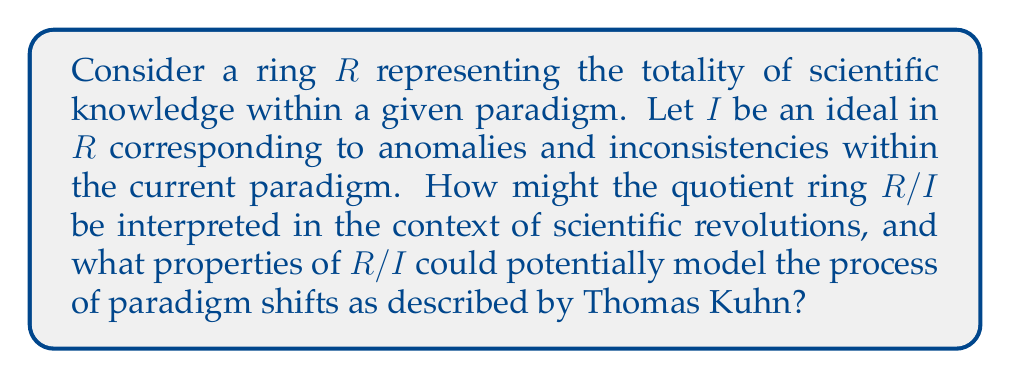Provide a solution to this math problem. To approach this question, we need to consider the properties of quotient rings and how they might relate to scientific revolutions and paradigm shifts:

1. Formation of $R/I$:
   The quotient ring $R/I$ is formed by identifying elements of $R$ that differ by an element of $I$. In the context of scientific revolutions, this can be interpreted as:
   - $R$ represents the entire body of scientific knowledge within a paradigm.
   - $I$ represents the set of anomalies, inconsistencies, and unexplained phenomena.
   - $R/I$ represents the "effective" scientific knowledge after accounting for these anomalies.

2. Properties of $R/I$:
   a) $R/I$ is a homomorphic image of $R$:
      This property can model how the new paradigm preserves some aspects of the old paradigm while fundamentally changing others.

   b) If $I$ is a proper ideal, $R/I$ is non-trivial:
      This suggests that even with anomalies, there is still a coherent body of scientific knowledge.

   c) The zero element in $R/I$ corresponds to the ideal $I$ in $R$:
      This can represent how anomalies and inconsistencies become "normalized" or "invisible" within the new paradigm.

3. Maximal ideals and paradigm shifts:
   If $I$ is a maximal ideal, then $R/I$ is a field. This could model a complete paradigm shift where the new scientific framework is fundamentally different and more "complete" in some sense.

4. Prime ideals and competing theories:
   If $I$ is a prime ideal but not maximal, $R/I$ is an integral domain but not a field. This might represent competing theories within a paradigm, each addressing some but not all anomalies.

5. Isomorphism theorems:
   The isomorphism theorems for rings could model how different formulations of a scientific theory might be equivalent at a deeper level.

Interpreting paradigm shifts:
- The process of forming $R/I$ can be seen as analogous to the accumulation of anomalies leading to a crisis in the current paradigm.
- The new ring structure of $R/I$ represents the reorganization of scientific knowledge in the new paradigm.
- The homomorphism from $R$ to $R/I$ models the retention of some aspects of the old paradigm within the new one.
- The "collapse" of elements differing by members of $I$ into single elements in $R/I$ could represent the resolution of previously unexplained phenomena in the new paradigm.

This mathematical model provides a framework for understanding Kuhn's description of scientific revolutions as involving a fundamental restructuring of scientific knowledge rather than a simple accumulation of facts.
Answer: The quotient ring $R/I$ can be interpreted as the restructured body of scientific knowledge after a paradigm shift, where anomalies (represented by the ideal $I$) have been resolved or recontextualized. Key properties of $R/I$ that model paradigm shifts include:

1. Its nature as a homomorphic image of $R$, preserving some structure while fundamentally altering others.
2. The potential for $R/I$ to be a field if $I$ is maximal, representing a complete paradigm shift.
3. The "normalization" of anomalies, represented by the ideal $I$ becoming the zero element in $R/I$.
4. The isomorphism theorems potentially modeling equivalences between different formulations of scientific theories.

These properties provide a mathematical framework for understanding the non-cumulative nature of scientific revolutions and the fundamental reorganization of knowledge that occurs during paradigm shifts. 